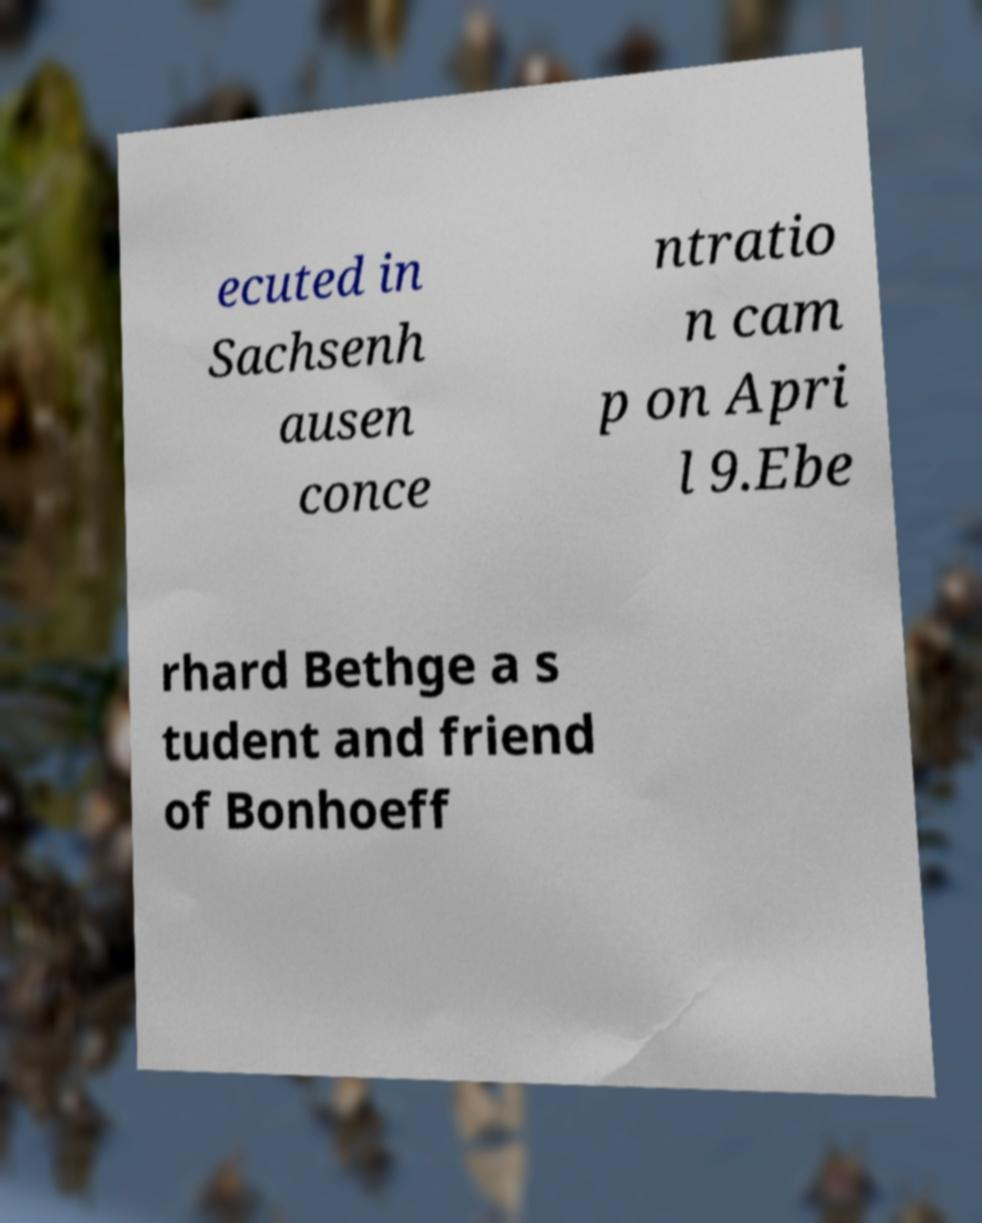Could you assist in decoding the text presented in this image and type it out clearly? ecuted in Sachsenh ausen conce ntratio n cam p on Apri l 9.Ebe rhard Bethge a s tudent and friend of Bonhoeff 